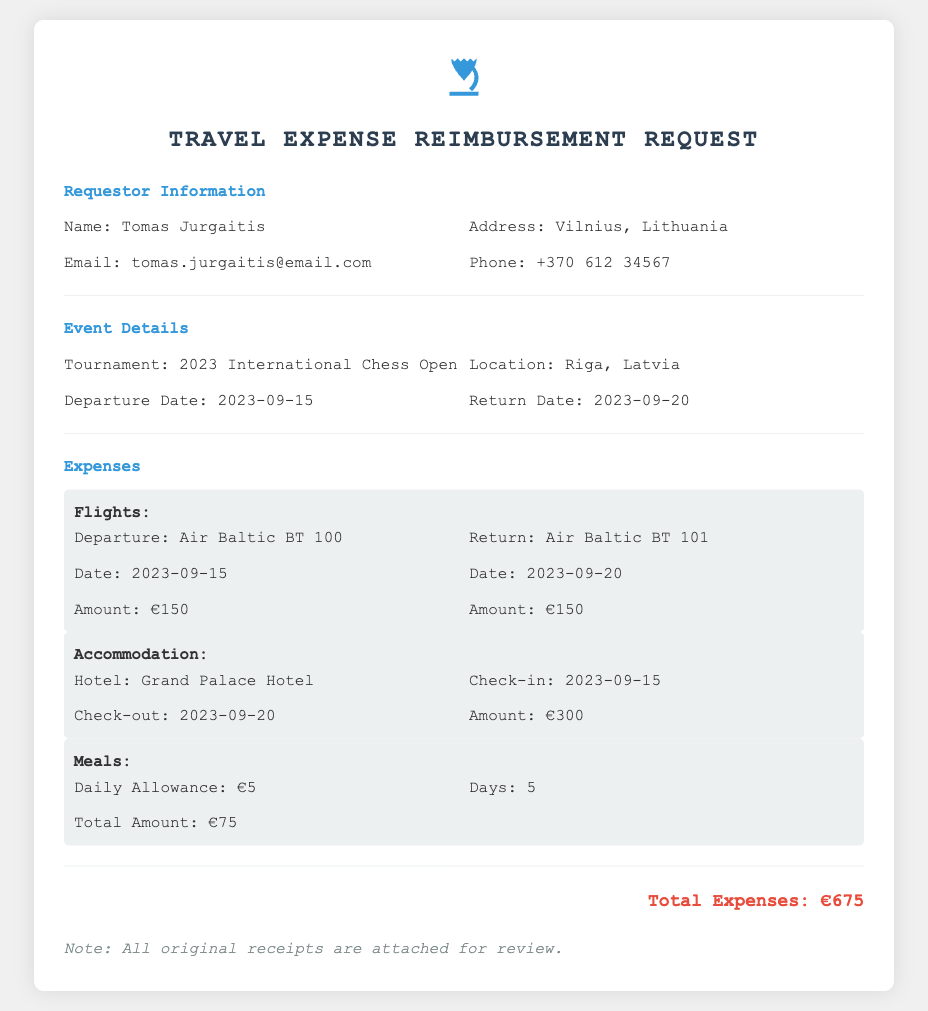What is the requestor's name? The requestor's name is specified in the document under "Requestor Information."
Answer: Tomas Jurgaitis What is the tournament name? The tournament name is mentioned in the "Event Details" section.
Answer: 2023 International Chess Open What was the departure date? The departure date can be found in the "Event Details" section.
Answer: 2023-09-15 What is the total amount for flights? The total amount for flights is listed in the "Expenses" section under "Flights."
Answer: €300 How many days was the daily meal allowance calculated for? The number of days for the meal allowance is stated under "Meals" in the "Expenses" section.
Answer: 5 What is the name of the hotel? The hotel name is found in the "Accommodation" subsection within "Expenses."
Answer: Grand Palace Hotel What is the calculation for total meals expense? The total meals expense is calculated by multiplying the daily allowance by the number of days, which is mentioned in the "Meals" section.
Answer: €75 Where is the tournament located? The location of the tournament is specified in the "Event Details" section.
Answer: Riga, Latvia What is the total expense amount? The total expense amount is provided at the end of the "Expenses" section.
Answer: €675 